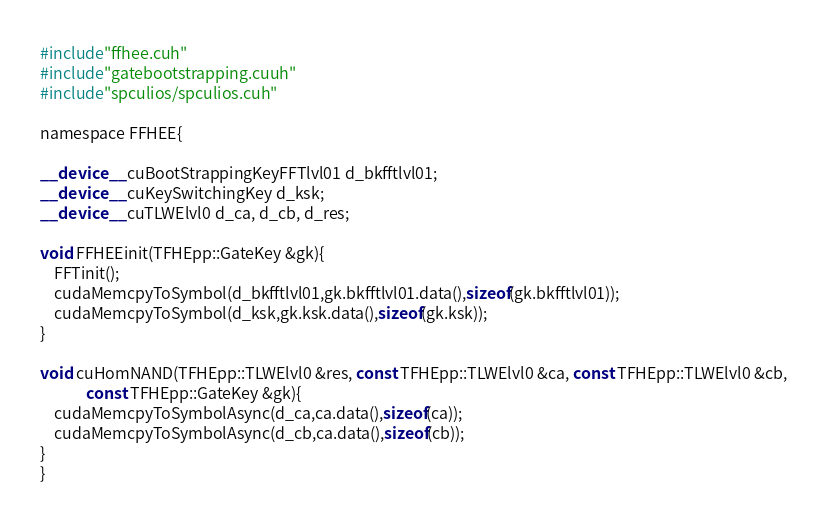Convert code to text. <code><loc_0><loc_0><loc_500><loc_500><_Cuda_>#include"ffhee.cuh"
#include"gatebootstrapping.cuuh"
#include"spculios/spculios.cuh"

namespace FFHEE{

__device__ cuBootStrappingKeyFFTlvl01 d_bkfftlvl01;
__device__ cuKeySwitchingKey d_ksk;
__device__ cuTLWElvl0 d_ca, d_cb, d_res;

void FFHEEinit(TFHEpp::GateKey &gk){
    FFTinit();
    cudaMemcpyToSymbol(d_bkfftlvl01,gk.bkfftlvl01.data(),sizeof(gk.bkfftlvl01));
    cudaMemcpyToSymbol(d_ksk,gk.ksk.data(),sizeof(gk.ksk));
}

void cuHomNAND(TFHEpp::TLWElvl0 &res, const TFHEpp::TLWElvl0 &ca, const TFHEpp::TLWElvl0 &cb,
             const TFHEpp::GateKey &gk){
    cudaMemcpyToSymbolAsync(d_ca,ca.data(),sizeof(ca));
    cudaMemcpyToSymbolAsync(d_cb,ca.data(),sizeof(cb));
}
}</code> 